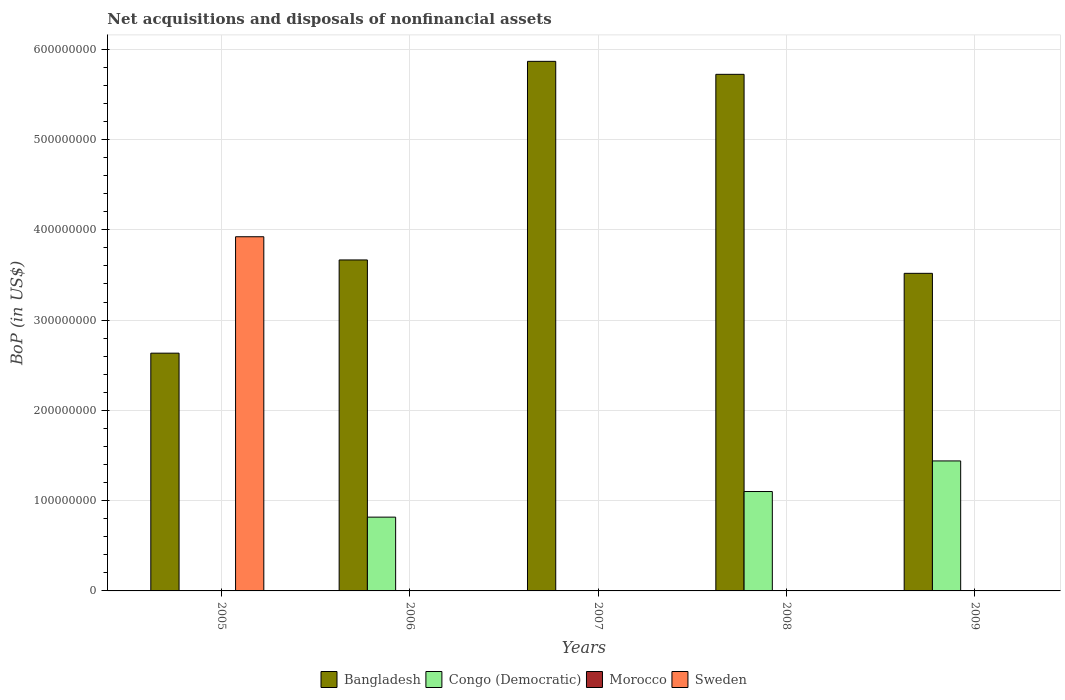Are the number of bars on each tick of the X-axis equal?
Make the answer very short. No. What is the label of the 5th group of bars from the left?
Your response must be concise. 2009. What is the Balance of Payments in Bangladesh in 2007?
Your answer should be compact. 5.87e+08. Across all years, what is the maximum Balance of Payments in Bangladesh?
Your response must be concise. 5.87e+08. Across all years, what is the minimum Balance of Payments in Morocco?
Keep it short and to the point. 0. In which year was the Balance of Payments in Bangladesh maximum?
Offer a terse response. 2007. What is the total Balance of Payments in Sweden in the graph?
Offer a terse response. 3.92e+08. What is the difference between the Balance of Payments in Bangladesh in 2005 and that in 2008?
Your response must be concise. -3.09e+08. What is the difference between the Balance of Payments in Morocco in 2005 and the Balance of Payments in Congo (Democratic) in 2009?
Ensure brevity in your answer.  -1.44e+08. What is the average Balance of Payments in Bangladesh per year?
Provide a short and direct response. 4.28e+08. What is the ratio of the Balance of Payments in Bangladesh in 2005 to that in 2007?
Offer a very short reply. 0.45. What is the difference between the highest and the second highest Balance of Payments in Bangladesh?
Your response must be concise. 1.44e+07. What is the difference between the highest and the lowest Balance of Payments in Bangladesh?
Offer a very short reply. 3.23e+08. In how many years, is the Balance of Payments in Congo (Democratic) greater than the average Balance of Payments in Congo (Democratic) taken over all years?
Offer a terse response. 3. Is it the case that in every year, the sum of the Balance of Payments in Sweden and Balance of Payments in Bangladesh is greater than the sum of Balance of Payments in Congo (Democratic) and Balance of Payments in Morocco?
Give a very brief answer. No. Is it the case that in every year, the sum of the Balance of Payments in Bangladesh and Balance of Payments in Morocco is greater than the Balance of Payments in Sweden?
Give a very brief answer. No. How many bars are there?
Provide a short and direct response. 9. Are all the bars in the graph horizontal?
Your answer should be very brief. No. What is the difference between two consecutive major ticks on the Y-axis?
Provide a succinct answer. 1.00e+08. Are the values on the major ticks of Y-axis written in scientific E-notation?
Give a very brief answer. No. Does the graph contain any zero values?
Your answer should be compact. Yes. How many legend labels are there?
Offer a very short reply. 4. How are the legend labels stacked?
Ensure brevity in your answer.  Horizontal. What is the title of the graph?
Provide a succinct answer. Net acquisitions and disposals of nonfinancial assets. What is the label or title of the Y-axis?
Provide a short and direct response. BoP (in US$). What is the BoP (in US$) in Bangladesh in 2005?
Your response must be concise. 2.63e+08. What is the BoP (in US$) in Morocco in 2005?
Your answer should be compact. 0. What is the BoP (in US$) of Sweden in 2005?
Your answer should be compact. 3.92e+08. What is the BoP (in US$) of Bangladesh in 2006?
Your answer should be compact. 3.67e+08. What is the BoP (in US$) of Congo (Democratic) in 2006?
Provide a short and direct response. 8.17e+07. What is the BoP (in US$) in Morocco in 2006?
Provide a short and direct response. 0. What is the BoP (in US$) of Sweden in 2006?
Your answer should be very brief. 0. What is the BoP (in US$) of Bangladesh in 2007?
Keep it short and to the point. 5.87e+08. What is the BoP (in US$) in Congo (Democratic) in 2007?
Offer a very short reply. 0. What is the BoP (in US$) of Morocco in 2007?
Offer a terse response. 0. What is the BoP (in US$) in Bangladesh in 2008?
Make the answer very short. 5.72e+08. What is the BoP (in US$) in Congo (Democratic) in 2008?
Keep it short and to the point. 1.10e+08. What is the BoP (in US$) in Bangladesh in 2009?
Offer a very short reply. 3.52e+08. What is the BoP (in US$) in Congo (Democratic) in 2009?
Ensure brevity in your answer.  1.44e+08. What is the BoP (in US$) in Morocco in 2009?
Your answer should be very brief. 0. What is the BoP (in US$) in Sweden in 2009?
Your answer should be compact. 0. Across all years, what is the maximum BoP (in US$) of Bangladesh?
Offer a very short reply. 5.87e+08. Across all years, what is the maximum BoP (in US$) in Congo (Democratic)?
Make the answer very short. 1.44e+08. Across all years, what is the maximum BoP (in US$) of Sweden?
Offer a terse response. 3.92e+08. Across all years, what is the minimum BoP (in US$) in Bangladesh?
Your answer should be very brief. 2.63e+08. Across all years, what is the minimum BoP (in US$) in Congo (Democratic)?
Give a very brief answer. 0. Across all years, what is the minimum BoP (in US$) in Sweden?
Make the answer very short. 0. What is the total BoP (in US$) of Bangladesh in the graph?
Give a very brief answer. 2.14e+09. What is the total BoP (in US$) in Congo (Democratic) in the graph?
Offer a terse response. 3.36e+08. What is the total BoP (in US$) of Sweden in the graph?
Your answer should be very brief. 3.92e+08. What is the difference between the BoP (in US$) of Bangladesh in 2005 and that in 2006?
Ensure brevity in your answer.  -1.03e+08. What is the difference between the BoP (in US$) of Bangladesh in 2005 and that in 2007?
Offer a very short reply. -3.23e+08. What is the difference between the BoP (in US$) in Bangladesh in 2005 and that in 2008?
Your response must be concise. -3.09e+08. What is the difference between the BoP (in US$) in Bangladesh in 2005 and that in 2009?
Give a very brief answer. -8.84e+07. What is the difference between the BoP (in US$) in Bangladesh in 2006 and that in 2007?
Give a very brief answer. -2.20e+08. What is the difference between the BoP (in US$) in Bangladesh in 2006 and that in 2008?
Provide a short and direct response. -2.06e+08. What is the difference between the BoP (in US$) in Congo (Democratic) in 2006 and that in 2008?
Your response must be concise. -2.84e+07. What is the difference between the BoP (in US$) of Bangladesh in 2006 and that in 2009?
Give a very brief answer. 1.48e+07. What is the difference between the BoP (in US$) in Congo (Democratic) in 2006 and that in 2009?
Keep it short and to the point. -6.22e+07. What is the difference between the BoP (in US$) in Bangladesh in 2007 and that in 2008?
Your answer should be compact. 1.44e+07. What is the difference between the BoP (in US$) in Bangladesh in 2007 and that in 2009?
Your response must be concise. 2.35e+08. What is the difference between the BoP (in US$) in Bangladesh in 2008 and that in 2009?
Provide a short and direct response. 2.20e+08. What is the difference between the BoP (in US$) in Congo (Democratic) in 2008 and that in 2009?
Your answer should be very brief. -3.39e+07. What is the difference between the BoP (in US$) of Bangladesh in 2005 and the BoP (in US$) of Congo (Democratic) in 2006?
Your response must be concise. 1.82e+08. What is the difference between the BoP (in US$) in Bangladesh in 2005 and the BoP (in US$) in Congo (Democratic) in 2008?
Your answer should be compact. 1.53e+08. What is the difference between the BoP (in US$) in Bangladesh in 2005 and the BoP (in US$) in Congo (Democratic) in 2009?
Ensure brevity in your answer.  1.19e+08. What is the difference between the BoP (in US$) in Bangladesh in 2006 and the BoP (in US$) in Congo (Democratic) in 2008?
Offer a very short reply. 2.56e+08. What is the difference between the BoP (in US$) in Bangladesh in 2006 and the BoP (in US$) in Congo (Democratic) in 2009?
Make the answer very short. 2.23e+08. What is the difference between the BoP (in US$) of Bangladesh in 2007 and the BoP (in US$) of Congo (Democratic) in 2008?
Keep it short and to the point. 4.76e+08. What is the difference between the BoP (in US$) of Bangladesh in 2007 and the BoP (in US$) of Congo (Democratic) in 2009?
Your answer should be compact. 4.43e+08. What is the difference between the BoP (in US$) in Bangladesh in 2008 and the BoP (in US$) in Congo (Democratic) in 2009?
Provide a short and direct response. 4.28e+08. What is the average BoP (in US$) in Bangladesh per year?
Give a very brief answer. 4.28e+08. What is the average BoP (in US$) in Congo (Democratic) per year?
Keep it short and to the point. 6.72e+07. What is the average BoP (in US$) in Morocco per year?
Make the answer very short. 0. What is the average BoP (in US$) in Sweden per year?
Make the answer very short. 7.85e+07. In the year 2005, what is the difference between the BoP (in US$) of Bangladesh and BoP (in US$) of Sweden?
Give a very brief answer. -1.29e+08. In the year 2006, what is the difference between the BoP (in US$) in Bangladesh and BoP (in US$) in Congo (Democratic)?
Your answer should be compact. 2.85e+08. In the year 2008, what is the difference between the BoP (in US$) in Bangladesh and BoP (in US$) in Congo (Democratic)?
Offer a very short reply. 4.62e+08. In the year 2009, what is the difference between the BoP (in US$) of Bangladesh and BoP (in US$) of Congo (Democratic)?
Provide a short and direct response. 2.08e+08. What is the ratio of the BoP (in US$) of Bangladesh in 2005 to that in 2006?
Offer a terse response. 0.72. What is the ratio of the BoP (in US$) in Bangladesh in 2005 to that in 2007?
Your answer should be compact. 0.45. What is the ratio of the BoP (in US$) in Bangladesh in 2005 to that in 2008?
Your answer should be compact. 0.46. What is the ratio of the BoP (in US$) of Bangladesh in 2005 to that in 2009?
Offer a very short reply. 0.75. What is the ratio of the BoP (in US$) in Bangladesh in 2006 to that in 2008?
Give a very brief answer. 0.64. What is the ratio of the BoP (in US$) in Congo (Democratic) in 2006 to that in 2008?
Give a very brief answer. 0.74. What is the ratio of the BoP (in US$) in Bangladesh in 2006 to that in 2009?
Your response must be concise. 1.04. What is the ratio of the BoP (in US$) in Congo (Democratic) in 2006 to that in 2009?
Ensure brevity in your answer.  0.57. What is the ratio of the BoP (in US$) of Bangladesh in 2007 to that in 2008?
Give a very brief answer. 1.03. What is the ratio of the BoP (in US$) in Bangladesh in 2007 to that in 2009?
Ensure brevity in your answer.  1.67. What is the ratio of the BoP (in US$) in Bangladesh in 2008 to that in 2009?
Keep it short and to the point. 1.63. What is the ratio of the BoP (in US$) of Congo (Democratic) in 2008 to that in 2009?
Make the answer very short. 0.76. What is the difference between the highest and the second highest BoP (in US$) in Bangladesh?
Keep it short and to the point. 1.44e+07. What is the difference between the highest and the second highest BoP (in US$) of Congo (Democratic)?
Your response must be concise. 3.39e+07. What is the difference between the highest and the lowest BoP (in US$) of Bangladesh?
Give a very brief answer. 3.23e+08. What is the difference between the highest and the lowest BoP (in US$) of Congo (Democratic)?
Your response must be concise. 1.44e+08. What is the difference between the highest and the lowest BoP (in US$) in Sweden?
Your answer should be compact. 3.92e+08. 